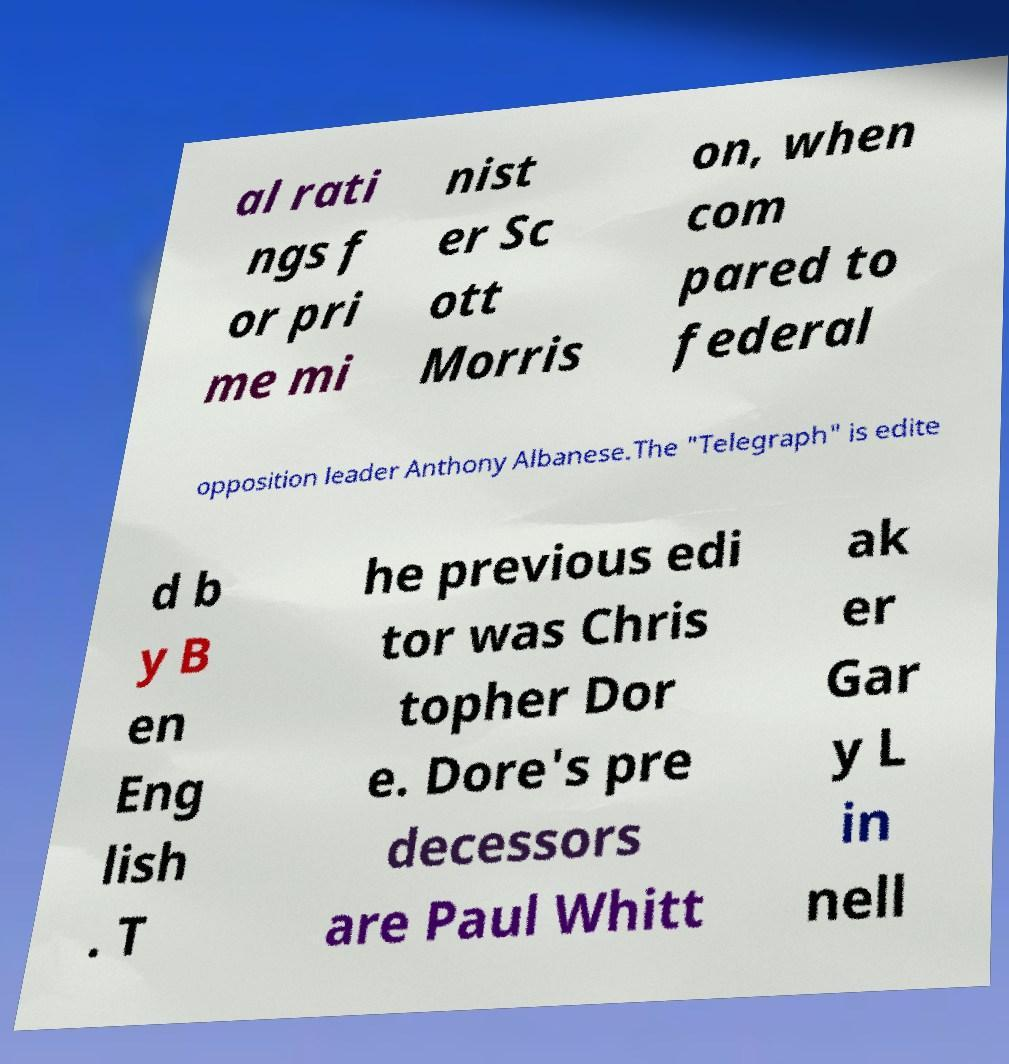What messages or text are displayed in this image? I need them in a readable, typed format. al rati ngs f or pri me mi nist er Sc ott Morris on, when com pared to federal opposition leader Anthony Albanese.The "Telegraph" is edite d b y B en Eng lish . T he previous edi tor was Chris topher Dor e. Dore's pre decessors are Paul Whitt ak er Gar y L in nell 